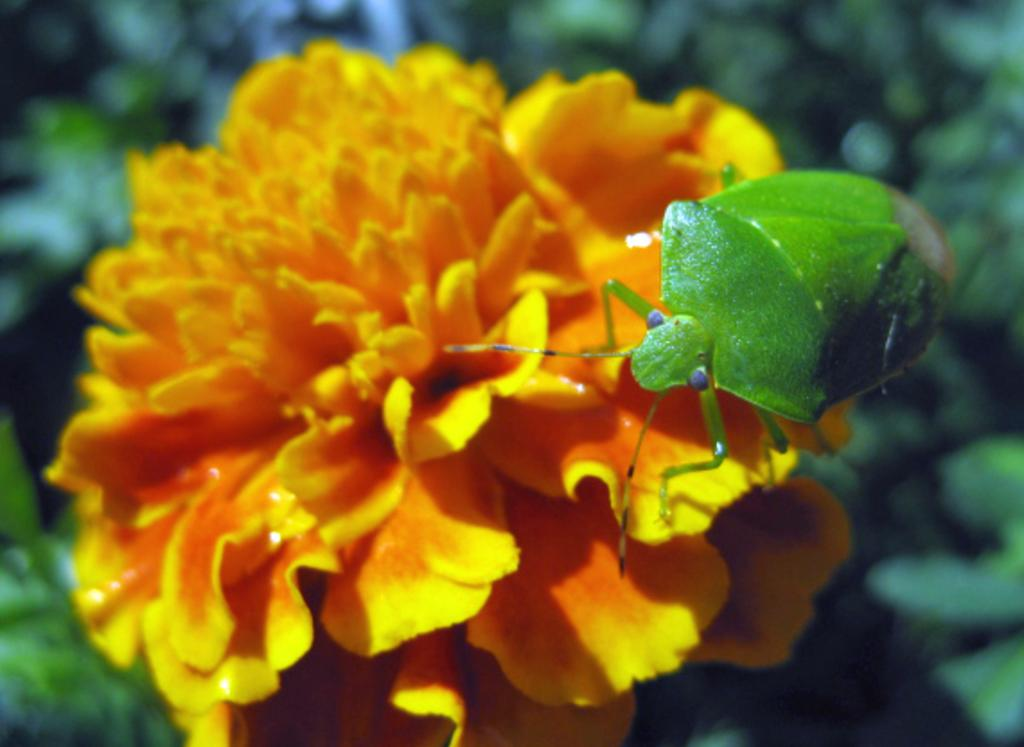What is on the flower in the image? There is an insect on a flower in the image. What can be seen in the background of the image? There are leaves visible in the background of the image. What type of sidewalk can be seen in the image? There is no sidewalk present in the image; it features an insect on a flower and leaves in the background. 